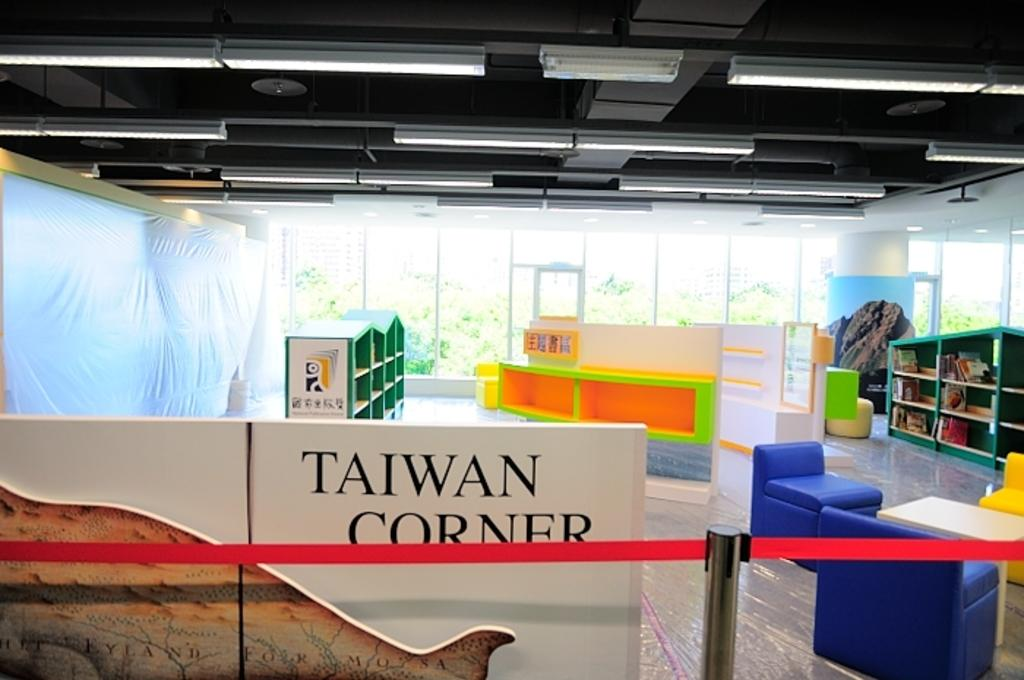<image>
Summarize the visual content of the image. Taiwan corner in a museum with bright color book shelves. 